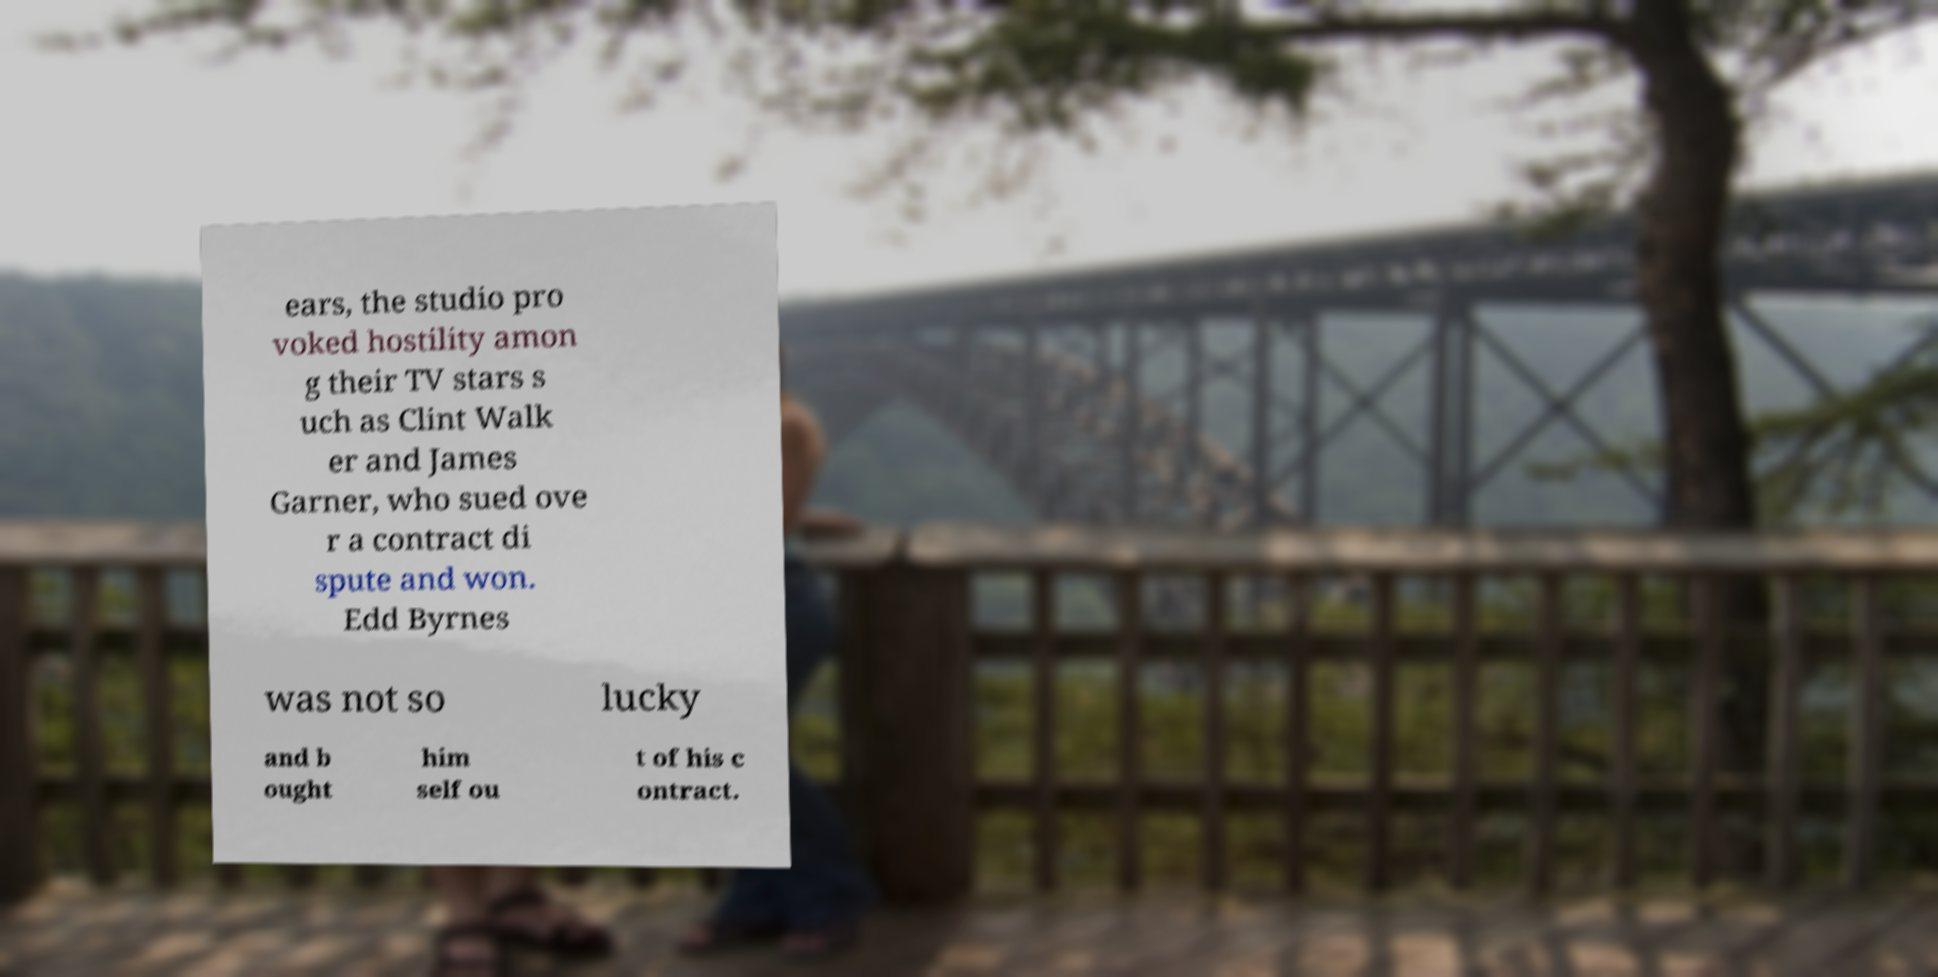What messages or text are displayed in this image? I need them in a readable, typed format. ears, the studio pro voked hostility amon g their TV stars s uch as Clint Walk er and James Garner, who sued ove r a contract di spute and won. Edd Byrnes was not so lucky and b ought him self ou t of his c ontract. 